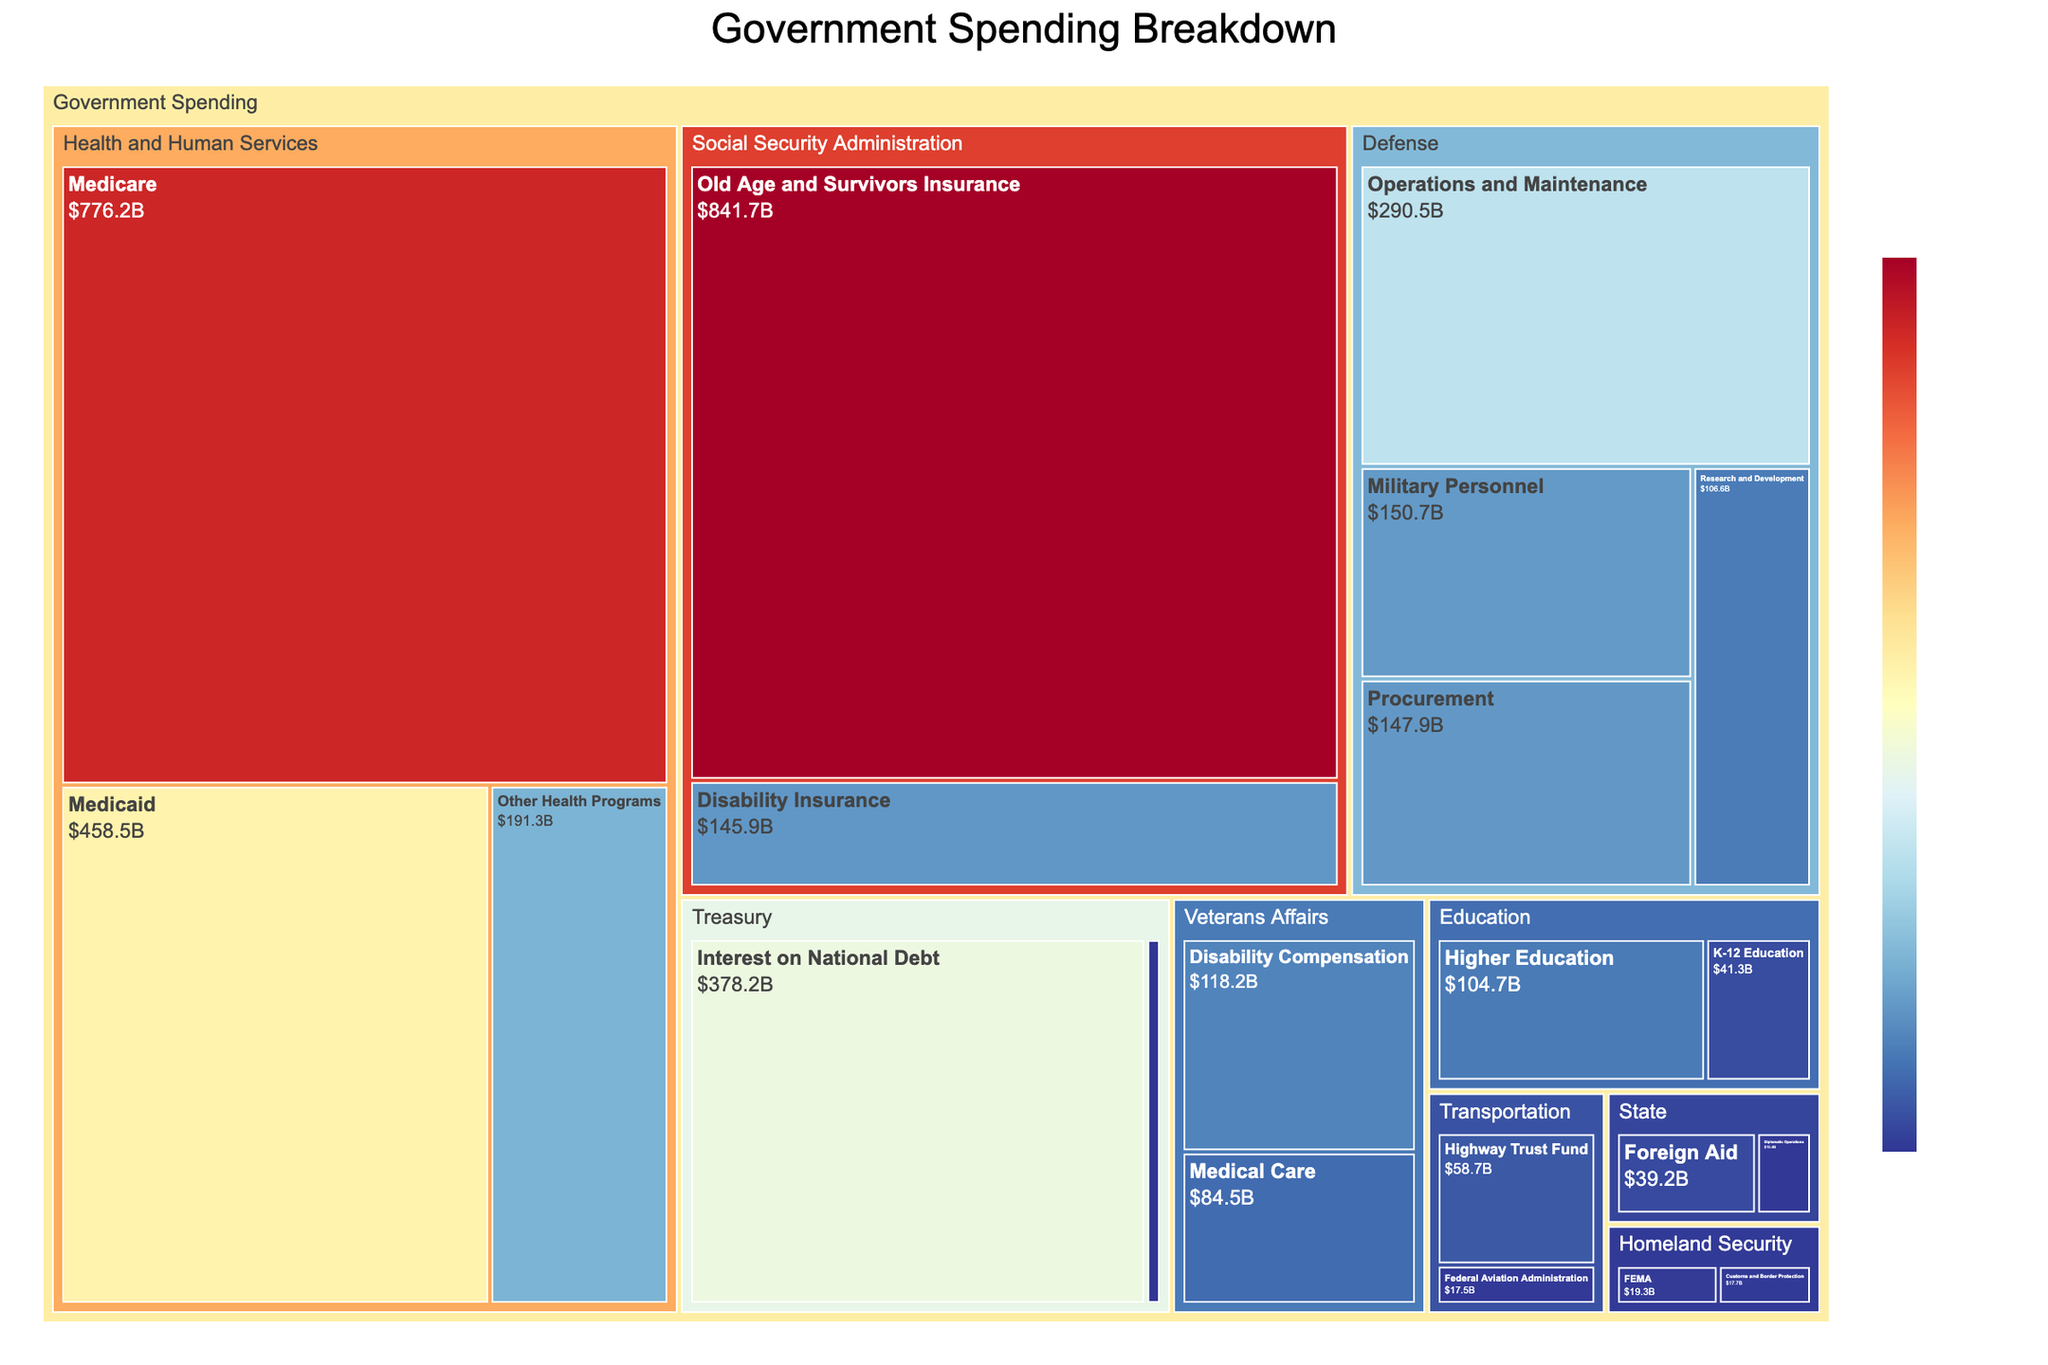What is the total spending for the Department of Defense? Combine the spending from Operations and Maintenance, Military Personnel, Procurement, and Research and Development: 290.5 + 150.7 + 147.9 + 106.6 = 695.7.
Answer: 695.7 billion Which sub-department of Health and Human Services has the highest spending? Compare the spending amounts for Medicare, Medicaid, and Other Health Programs. Medicare has the highest spending at 776.2 billion.
Answer: Medicare How does spending on Higher Education compare to spending on K-12 Education within the Department of Education? The spending on Higher Education is 104.7 billion, while the spending on K-12 Education is 41.3 billion. Higher Education has higher spending.
Answer: Higher Education has higher spending What is the total spending of the Social Security Administration? Sum the spending for Old Age and Survivors Insurance and Disability Insurance: 841.7 + 145.9 = 987.6.
Answer: 987.6 billion What is the smallest sub-departmental spending in the treemap? Identify the smallest spending value in the figure, which is IRS Operations at 12.9 billion.
Answer: IRS Operations Which department has the highest total spending? Based on the combined values for departments, Health and Human Services has the highest total spending (776.2 + 458.5 + 191.3 = 1426.0 billion).
Answer: Health and Human Services How does the spending on Military Personnel within the Department of Defense compare to the spending on Medicaid within Health and Human Services? Military Personnel spending is 150.7 billion, while Medicaid spending is 458.5 billion. Medicaid spending is higher.
Answer: Medicaid spending is higher What is the total spending for Homeland Security? Add the spending for Customs and Border Protection and FEMA: 17.7 + 19.3 = 37.0.
Answer: 37.0 billion Which sub-department spends more: Disability Compensation within Veterans Affairs or Interest on National Debt within the Treasury? Compare the spending amounts: Disability Compensation is 118.2 billion, while Interest on National Debt is 378.2 billion. Interest on National Debt spends more.
Answer: Interest on National Debt spends more What is the average spending of the sub-departments within the Department of State? Calculate the average of Diplomatic Operations and Foreign Aid: (15.4 + 39.2) / 2 = 27.3.
Answer: 27.3 billion 